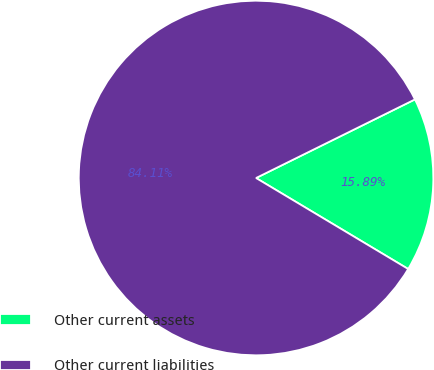<chart> <loc_0><loc_0><loc_500><loc_500><pie_chart><fcel>Other current assets<fcel>Other current liabilities<nl><fcel>15.89%<fcel>84.11%<nl></chart> 